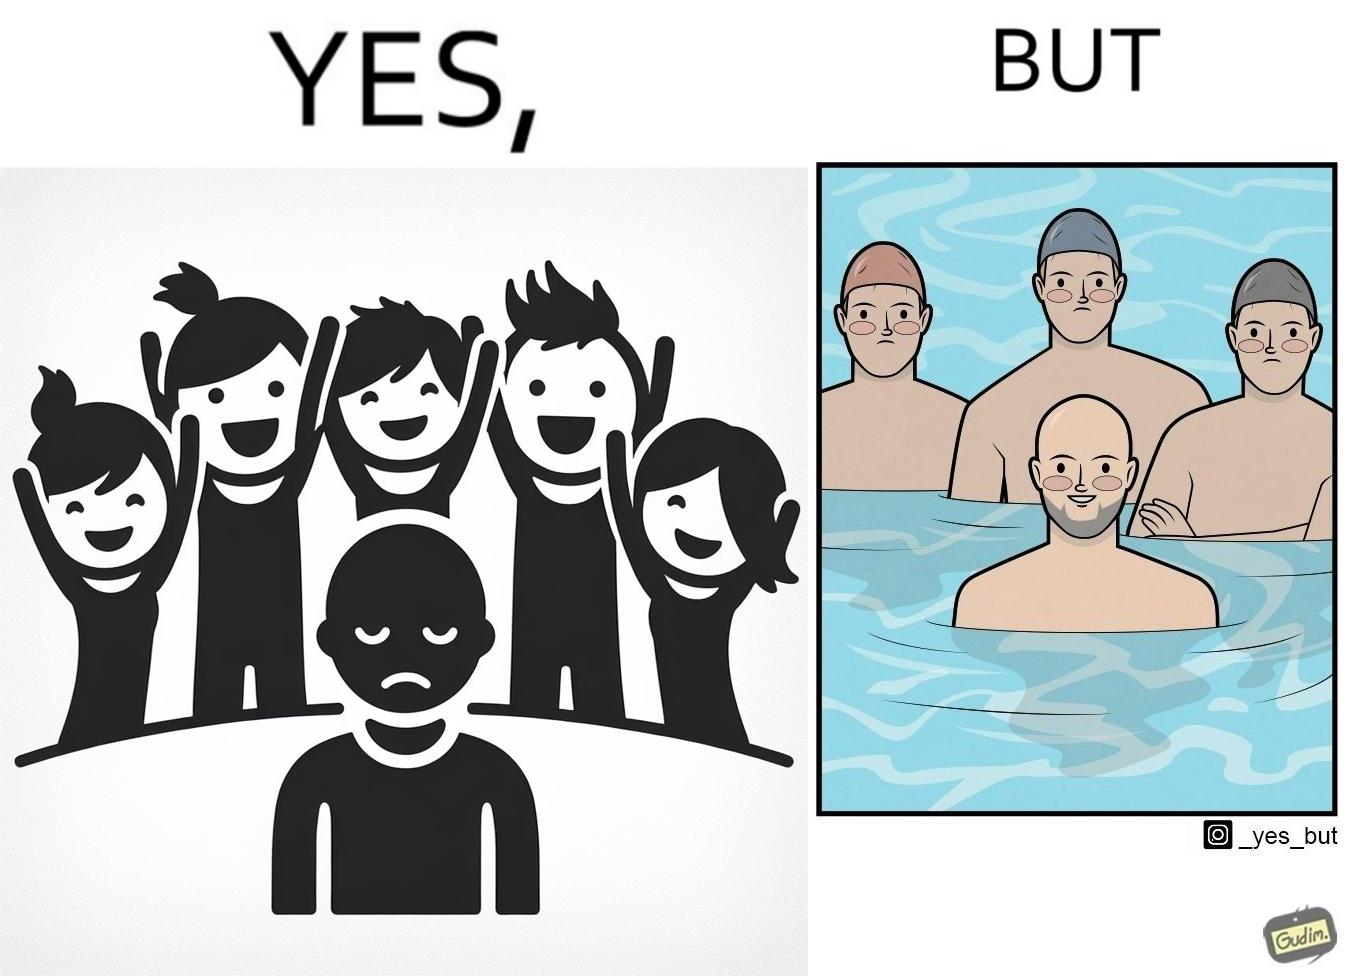Why is this image considered satirical? The image is ironical, as person without hair is sad in a normal situation due to the absence of hair, unlike other people with hair. However, in a swimming pool, people with hair have to wear swimming caps, which is uncomfortable, while the person without hair does not need a cap, and is thus, happy in this situation. 